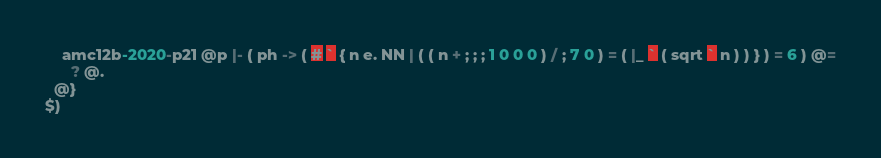Convert code to text. <code><loc_0><loc_0><loc_500><loc_500><_ObjectiveC_>    amc12b-2020-p21 @p |- ( ph -> ( # ` { n e. NN | ( ( n + ; ; ; 1 0 0 0 ) / ; 7 0 ) = ( |_ ` ( sqrt ` n ) ) } ) = 6 ) @=
      ? @.
  @}
$)
</code> 